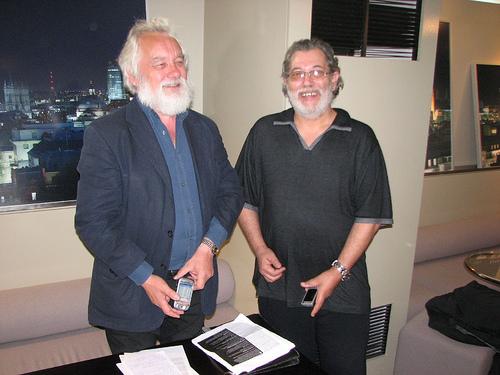What are both men holding?
Short answer required. Phones. Does everyone have a beard?
Be succinct. Yes. Is this building taller than two stories?
Keep it brief. Yes. Do both men have beards?
Concise answer only. Yes. 